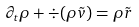<formula> <loc_0><loc_0><loc_500><loc_500>\partial _ { t } \rho + \div ( \rho \tilde { v } ) = \rho \tilde { r }</formula> 